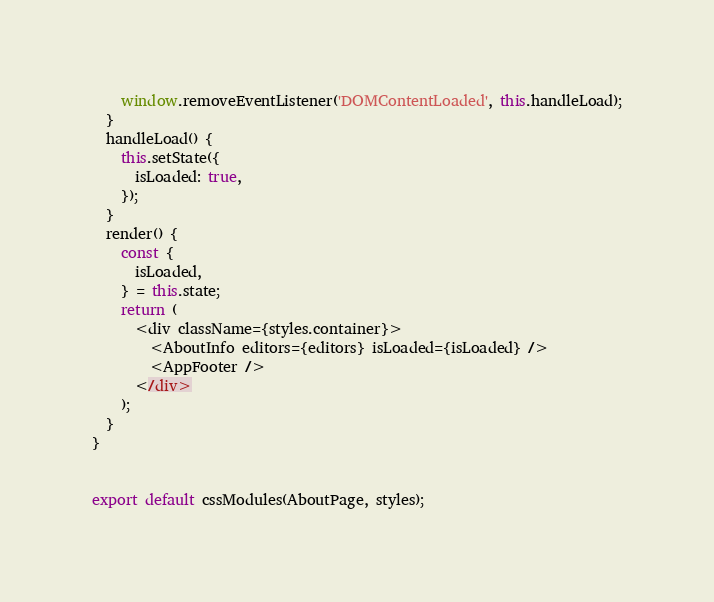Convert code to text. <code><loc_0><loc_0><loc_500><loc_500><_JavaScript_>    window.removeEventListener('DOMContentLoaded', this.handleLoad);
  }
  handleLoad() {
    this.setState({
      isLoaded: true,
    });
  }
  render() {
    const {
      isLoaded,
    } = this.state;
    return (
      <div className={styles.container}>
        <AboutInfo editors={editors} isLoaded={isLoaded} />
        <AppFooter />
      </div>
    );
  }
}


export default cssModules(AboutPage, styles);
</code> 